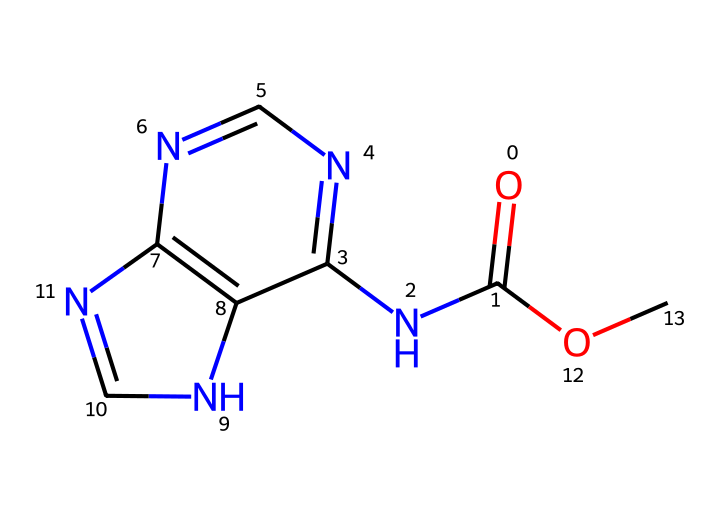What is the primary functional group in carbendazim? The primary functional group is a carbamate, which is indicated by the presence of the carbonyl (C=O) adjacent to the nitrogen (N). This is coupled with the ether (R-O-R') from the -OC part of the structure.
Answer: carbamate How many nitrogen atoms are present in the chemical structure of carbendazim? By examining the SMILES representation, we can identify that there are three nitrogen atoms (N) in the structure, all of which are part of different ring systems.
Answer: three What type of bond connects the carbon and the nitrogen in carbendazim? The bond that connects carbon and nitrogen in carbendazim is a covalent bond, as both elements share electrons to form a stable bond.
Answer: covalent What is the total number of rings in the carbendazim structure? The SMILES representation shows two nitrogen-containing rings in the structure, which are part of the fused bicyclic system found in carbendazim.
Answer: two How does the structure of carbendazim contribute to its function as a fungicide? The multi-ring structure containing nitrogen atoms allows for interaction with fungal cell processes, inhibiting growth and reproduction, which is crucial for its function as a fungicide.
Answer: multi-ring structure 